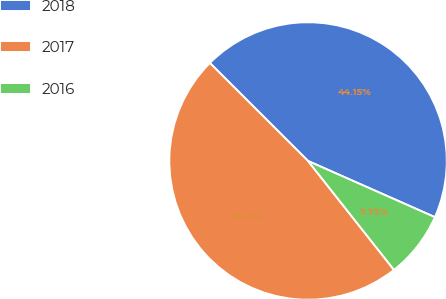Convert chart. <chart><loc_0><loc_0><loc_500><loc_500><pie_chart><fcel>2018<fcel>2017<fcel>2016<nl><fcel>44.15%<fcel>48.12%<fcel>7.73%<nl></chart> 